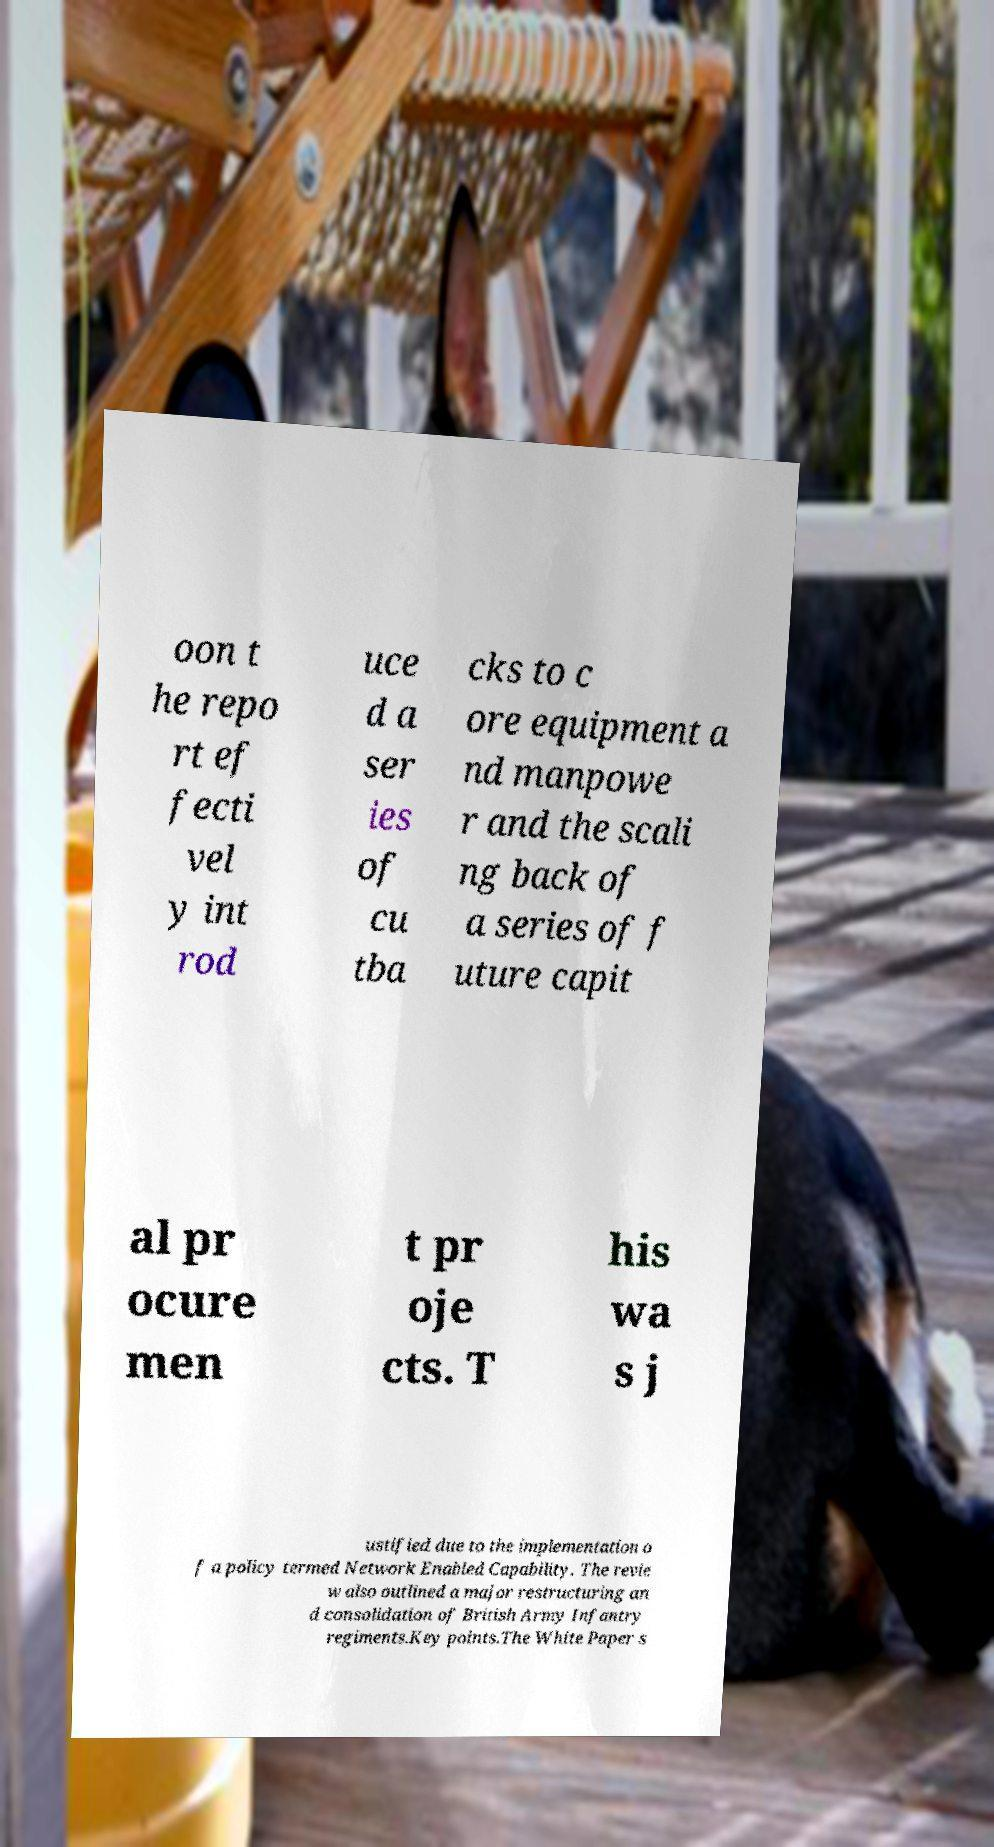Can you read and provide the text displayed in the image?This photo seems to have some interesting text. Can you extract and type it out for me? oon t he repo rt ef fecti vel y int rod uce d a ser ies of cu tba cks to c ore equipment a nd manpowe r and the scali ng back of a series of f uture capit al pr ocure men t pr oje cts. T his wa s j ustified due to the implementation o f a policy termed Network Enabled Capability. The revie w also outlined a major restructuring an d consolidation of British Army Infantry regiments.Key points.The White Paper s 